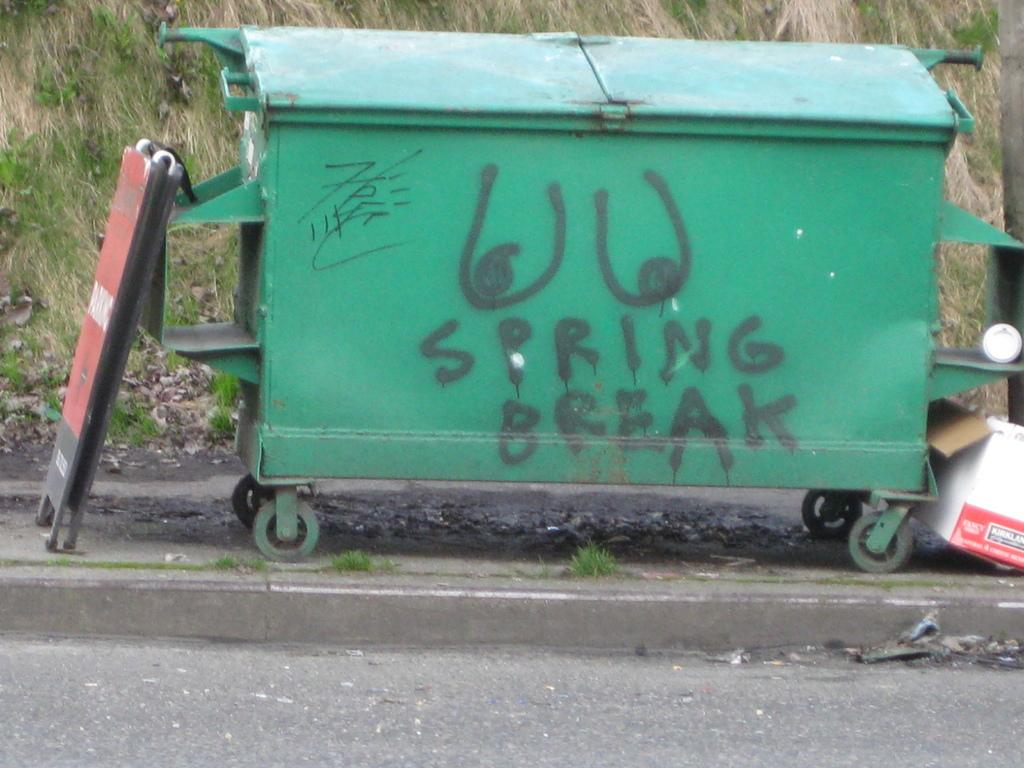Provide a one-sentence caption for the provided image. A green dumpster with graffiti on it and spray painted words "spring break". 